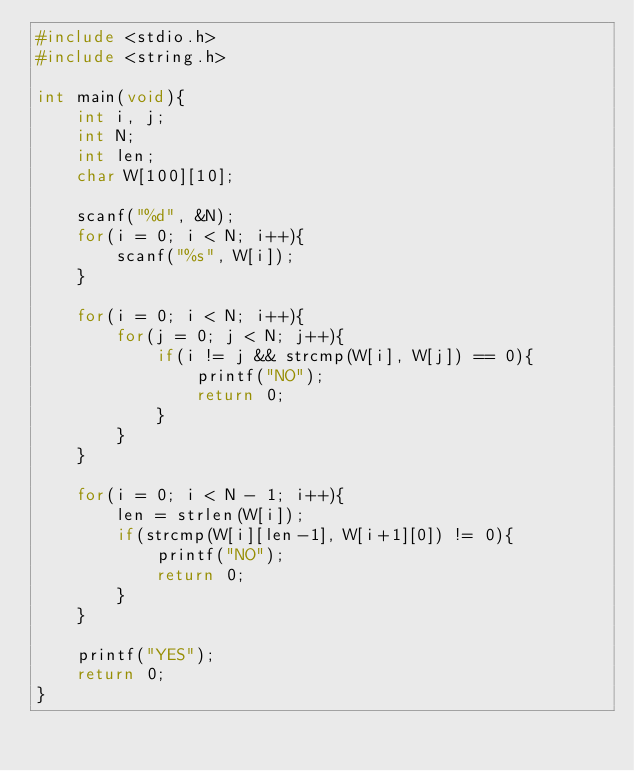<code> <loc_0><loc_0><loc_500><loc_500><_C_>#include <stdio.h>
#include <string.h>

int main(void){
    int i, j;
    int N;
    int len;
    char W[100][10];
    
    scanf("%d", &N);
    for(i = 0; i < N; i++){
        scanf("%s", W[i]);
    }
    
    for(i = 0; i < N; i++){
        for(j = 0; j < N; j++){
            if(i != j && strcmp(W[i], W[j]) == 0){
                printf("NO");
                return 0;
            }
        }
    }
    
    for(i = 0; i < N - 1; i++){
        len = strlen(W[i]);
        if(strcmp(W[i][len-1], W[i+1][0]) != 0){
            printf("NO");
            return 0;
        }
    }
    
    printf("YES");
    return 0;
}</code> 